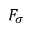Convert formula to latex. <formula><loc_0><loc_0><loc_500><loc_500>F _ { \sigma }</formula> 